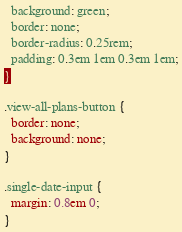<code> <loc_0><loc_0><loc_500><loc_500><_CSS_>  background: green;
  border: none;
  border-radius: 0.25rem;
  padding: 0.3em 1em 0.3em 1em;
}

.view-all-plans-button {
  border: none;
  background: none;
}

.single-date-input {
  margin: 0.8em 0;
}
</code> 